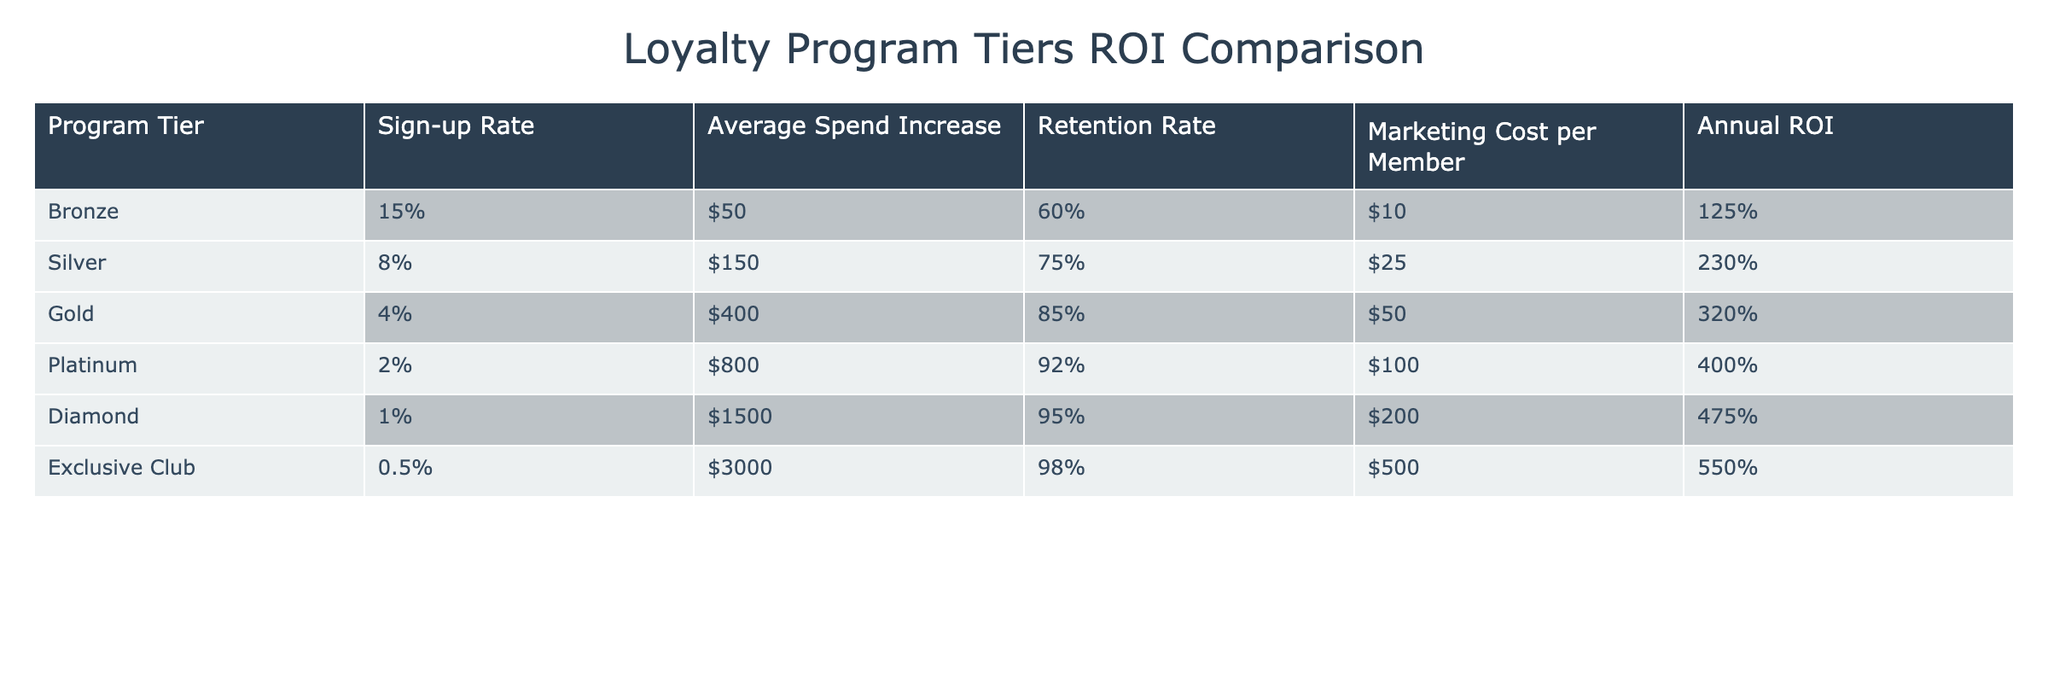What is the retention rate for the Gold tier? The Gold tier has a retention rate listed in the table, which is directly stated as 85%.
Answer: 85% Which loyalty program tier has the highest marketing cost per member? By comparing the marketing costs in the table, the Diamond tier has the highest cost at $200 per member.
Answer: Diamond How much does the Silver tier increase average spending compared to the Bronze tier? The average spend increase for the Silver tier is $150, and for the Bronze tier, it is $50. To find the difference, subtract: $150 - $50 = $100.
Answer: $100 True or false: The Platinum tier has a higher average spend increase than the Gold tier. The average spend increase for the Platinum tier is $800, while it is $400 for the Gold tier. Since $800 is greater than $400, the statement is true.
Answer: True What is the overall ROI of all tiers combined? To calculate the overall ROI, we take all individual ROIs: (125 + 230 + 320 + 400 + 475 + 550) = 2100. Since there are 6 tiers, the average ROI is 2100 / 6 = 350%.
Answer: 350% Which tier has the lowest sign-up rate and how much is it? The tier with the lowest sign-up rate is the Exclusive Club, with a rate of 0.5%. This information is found directly in the table.
Answer: 0.5% If we compare the loyalty program tiers' annual ROI, which one is more than 300%? The tiers with an ROI greater than 300% are Gold (320%), Platinum (400%), Diamond (475%), and Exclusive Club (550%).
Answer: Gold, Platinum, Diamond, Exclusive Club What is the average marketing cost across all tiers? To find the average marketing cost, we sum the costs: (10 + 25 + 50 + 100 + 200 + 500) = 885, then divide by the number of tiers (6): 885 / 6 = 147.5.
Answer: 147.5 